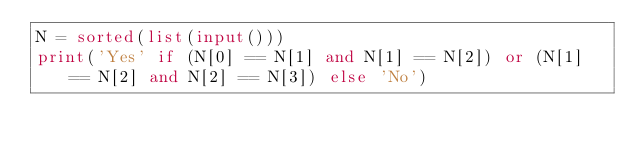<code> <loc_0><loc_0><loc_500><loc_500><_Python_>N = sorted(list(input()))
print('Yes' if (N[0] == N[1] and N[1] == N[2]) or (N[1] == N[2] and N[2] == N[3]) else 'No')
</code> 